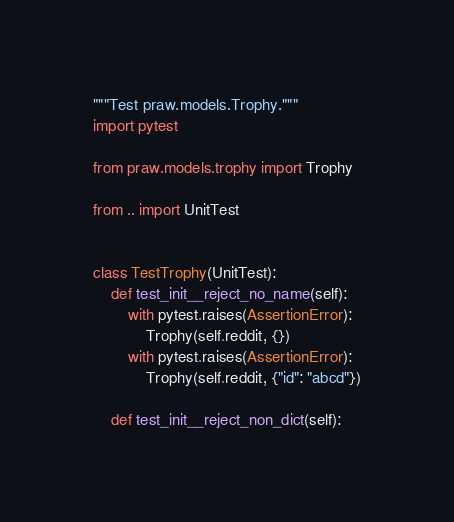Convert code to text. <code><loc_0><loc_0><loc_500><loc_500><_Python_>"""Test praw.models.Trophy."""
import pytest

from praw.models.trophy import Trophy

from .. import UnitTest


class TestTrophy(UnitTest):
    def test_init__reject_no_name(self):
        with pytest.raises(AssertionError):
            Trophy(self.reddit, {})
        with pytest.raises(AssertionError):
            Trophy(self.reddit, {"id": "abcd"})

    def test_init__reject_non_dict(self):</code> 